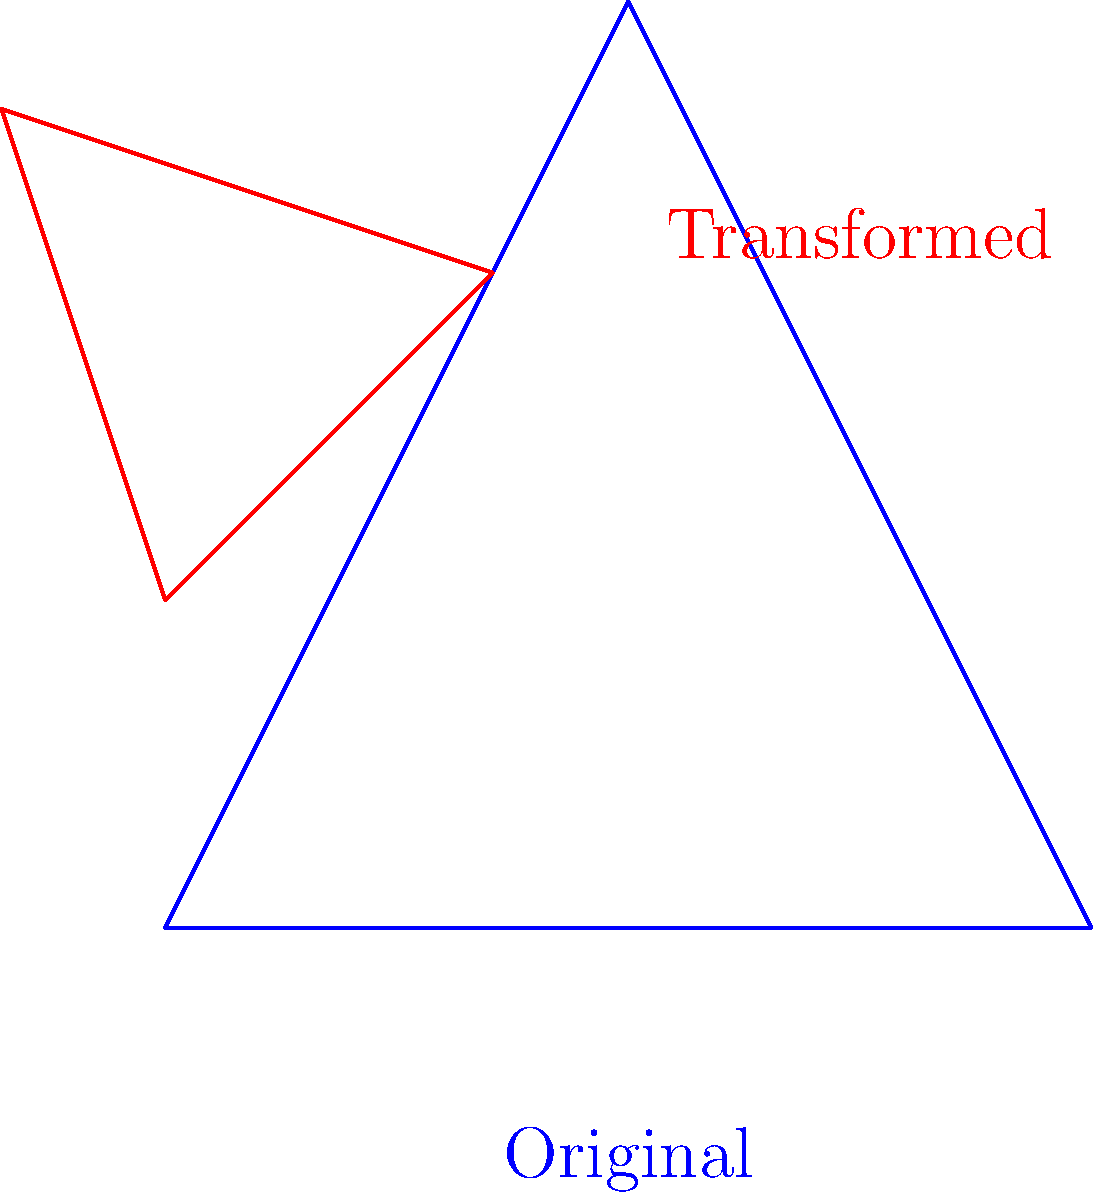The Tesla autopilot symbol, represented by a simple triangle, undergoes a series of transformations to illustrate its unreliability. The original blue triangle is transformed into the red triangle through the following sequence: a translation of (1,1), a rotation of 45°, and a scaling by a factor of 0.5. If the area of the original triangle is 2 square units, what is the area of the transformed red triangle? Let's approach this step-by-step:

1) The original area of the triangle is given as 2 square units.

2) The transformations applied are:
   a) Translation: This doesn't affect the area.
   b) Rotation: This also doesn't affect the area.
   c) Scaling: This is the only transformation that changes the area.

3) The scaling factor is 0.5, which means each dimension is halved.

4) When a two-dimensional shape is scaled by a factor of k, its area is scaled by a factor of $k^2$.

5) In this case, $k = 0.5$, so the area scaling factor is:

   $k^2 = (0.5)^2 = 0.25$

6) Therefore, the new area will be:

   New Area = Original Area × $0.25$
            = $2 \times 0.25$
            = $0.5$ square units
Answer: 0.5 square units 